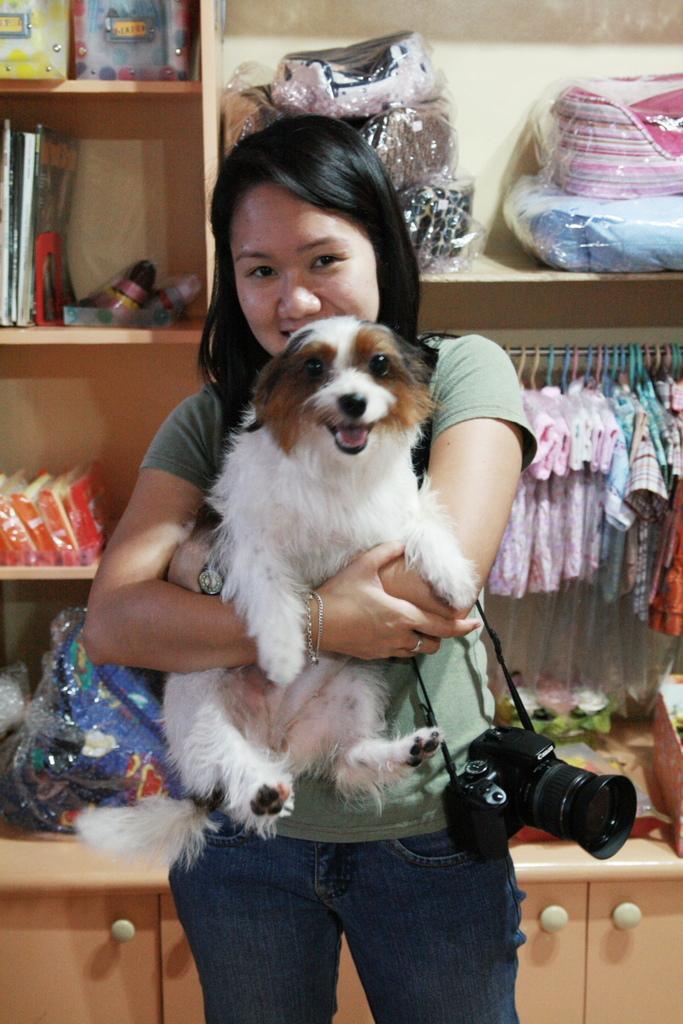Can you describe this image briefly? On the background we can see a rack and in a rack we can see packets, books, bottles, boxes and clothes are arranged. Here we can see a woman with short hair holding a camera and a dog in her hands. She has a black colour short hair. 